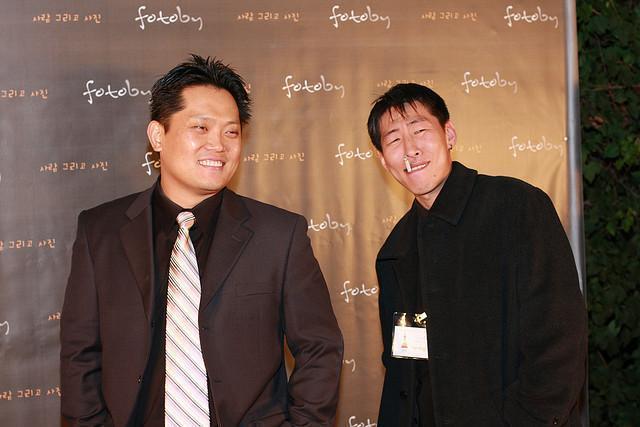How many people are in the photo?
Give a very brief answer. 2. 